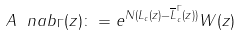<formula> <loc_0><loc_0><loc_500><loc_500>A ^ { \ } n a b _ { \Gamma } ( z ) \colon = e ^ { N ( L _ { c } ( z ) - \overline { L } _ { c } ^ { \Gamma } ( z ) ) } W ( z )</formula> 